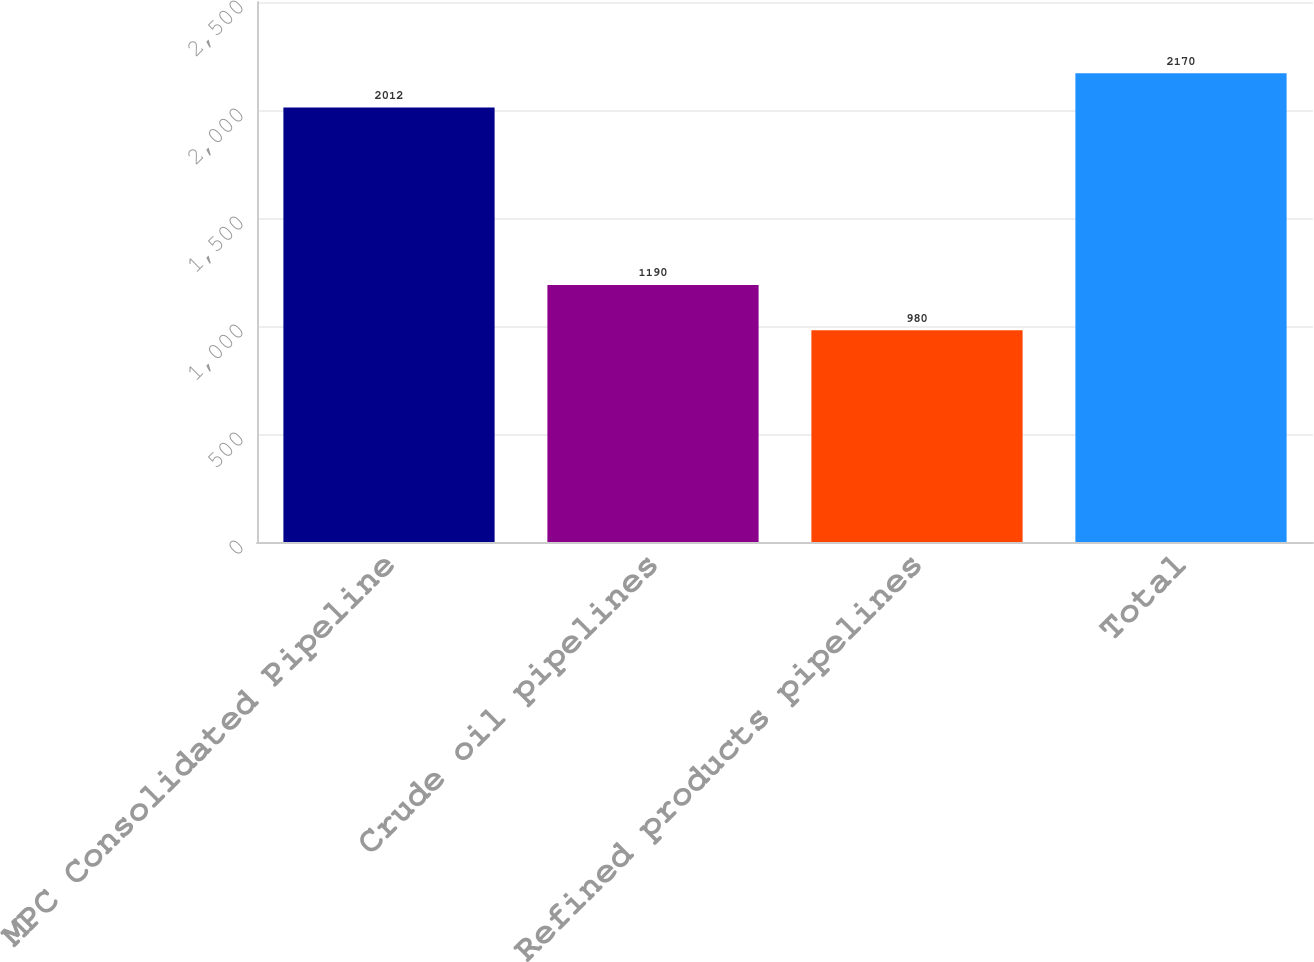Convert chart. <chart><loc_0><loc_0><loc_500><loc_500><bar_chart><fcel>MPC Consolidated Pipeline<fcel>Crude oil pipelines<fcel>Refined products pipelines<fcel>Total<nl><fcel>2012<fcel>1190<fcel>980<fcel>2170<nl></chart> 